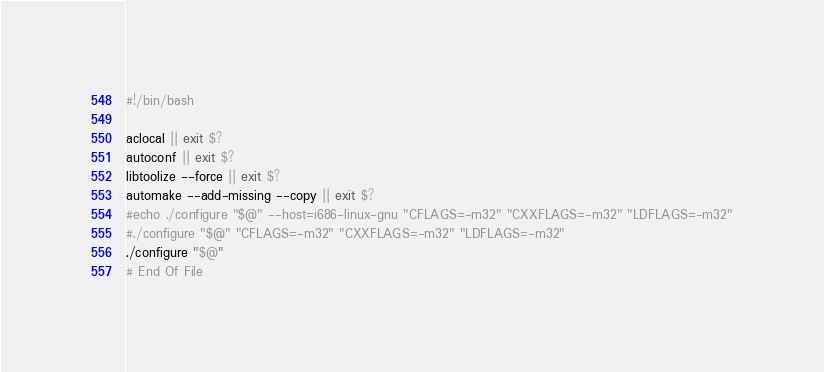Convert code to text. <code><loc_0><loc_0><loc_500><loc_500><_Bash_>#!/bin/bash

aclocal || exit $?
autoconf || exit $?
libtoolize --force || exit $?
automake --add-missing --copy || exit $?
#echo ./configure "$@" --host=i686-linux-gnu "CFLAGS=-m32" "CXXFLAGS=-m32" "LDFLAGS=-m32"
#./configure "$@" "CFLAGS=-m32" "CXXFLAGS=-m32" "LDFLAGS=-m32"
./configure "$@"
# End Of File
</code> 